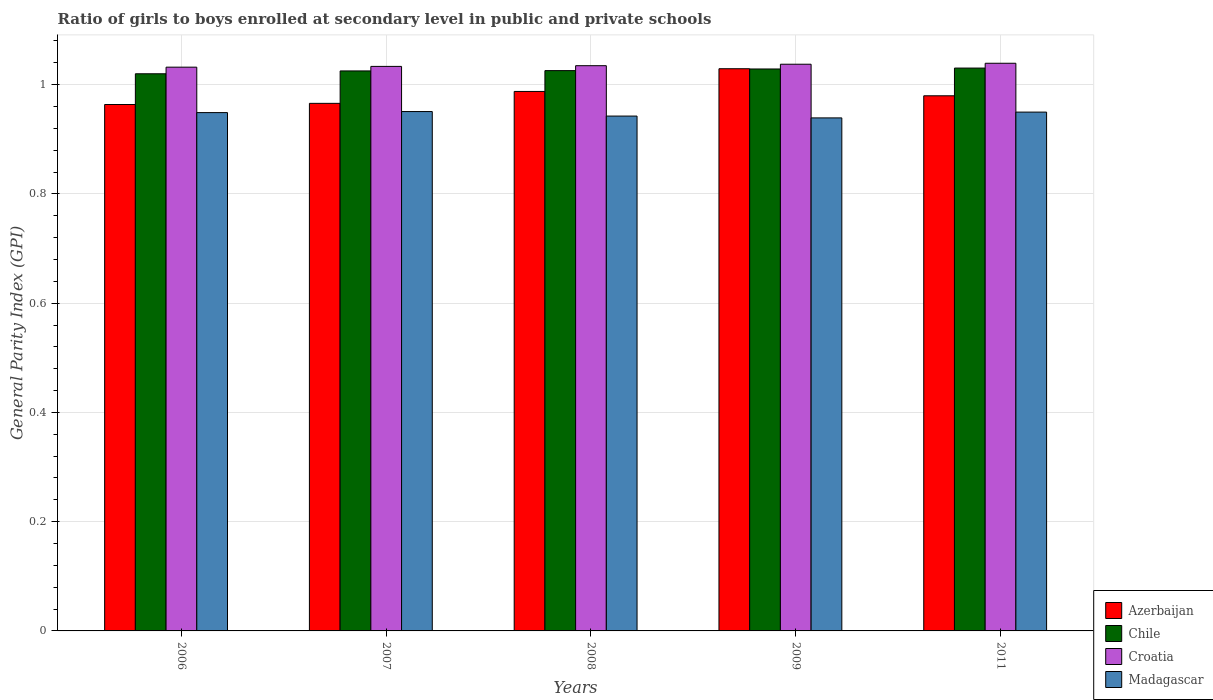What is the general parity index in Madagascar in 2008?
Provide a succinct answer. 0.94. Across all years, what is the maximum general parity index in Chile?
Provide a succinct answer. 1.03. Across all years, what is the minimum general parity index in Madagascar?
Provide a short and direct response. 0.94. In which year was the general parity index in Chile minimum?
Your response must be concise. 2006. What is the total general parity index in Azerbaijan in the graph?
Your answer should be very brief. 4.93. What is the difference between the general parity index in Chile in 2006 and that in 2008?
Provide a short and direct response. -0.01. What is the difference between the general parity index in Madagascar in 2011 and the general parity index in Chile in 2009?
Provide a succinct answer. -0.08. What is the average general parity index in Croatia per year?
Keep it short and to the point. 1.04. In the year 2006, what is the difference between the general parity index in Croatia and general parity index in Azerbaijan?
Give a very brief answer. 0.07. In how many years, is the general parity index in Madagascar greater than 0.04?
Your response must be concise. 5. What is the ratio of the general parity index in Croatia in 2007 to that in 2008?
Ensure brevity in your answer.  1. Is the difference between the general parity index in Croatia in 2007 and 2011 greater than the difference between the general parity index in Azerbaijan in 2007 and 2011?
Ensure brevity in your answer.  Yes. What is the difference between the highest and the second highest general parity index in Chile?
Make the answer very short. 0. What is the difference between the highest and the lowest general parity index in Madagascar?
Keep it short and to the point. 0.01. Is the sum of the general parity index in Azerbaijan in 2007 and 2008 greater than the maximum general parity index in Croatia across all years?
Ensure brevity in your answer.  Yes. Is it the case that in every year, the sum of the general parity index in Chile and general parity index in Azerbaijan is greater than the sum of general parity index in Croatia and general parity index in Madagascar?
Provide a succinct answer. Yes. What does the 4th bar from the left in 2007 represents?
Give a very brief answer. Madagascar. What does the 1st bar from the right in 2008 represents?
Provide a short and direct response. Madagascar. Is it the case that in every year, the sum of the general parity index in Madagascar and general parity index in Chile is greater than the general parity index in Croatia?
Keep it short and to the point. Yes. How many bars are there?
Your response must be concise. 20. Are all the bars in the graph horizontal?
Provide a short and direct response. No. Does the graph contain any zero values?
Offer a very short reply. No. Does the graph contain grids?
Offer a very short reply. Yes. How many legend labels are there?
Ensure brevity in your answer.  4. What is the title of the graph?
Give a very brief answer. Ratio of girls to boys enrolled at secondary level in public and private schools. What is the label or title of the X-axis?
Offer a very short reply. Years. What is the label or title of the Y-axis?
Offer a very short reply. General Parity Index (GPI). What is the General Parity Index (GPI) of Azerbaijan in 2006?
Offer a terse response. 0.96. What is the General Parity Index (GPI) of Chile in 2006?
Your answer should be compact. 1.02. What is the General Parity Index (GPI) in Croatia in 2006?
Provide a succinct answer. 1.03. What is the General Parity Index (GPI) of Madagascar in 2006?
Provide a short and direct response. 0.95. What is the General Parity Index (GPI) in Azerbaijan in 2007?
Keep it short and to the point. 0.97. What is the General Parity Index (GPI) in Chile in 2007?
Ensure brevity in your answer.  1.03. What is the General Parity Index (GPI) of Croatia in 2007?
Offer a very short reply. 1.03. What is the General Parity Index (GPI) of Madagascar in 2007?
Give a very brief answer. 0.95. What is the General Parity Index (GPI) of Azerbaijan in 2008?
Ensure brevity in your answer.  0.99. What is the General Parity Index (GPI) in Chile in 2008?
Offer a very short reply. 1.03. What is the General Parity Index (GPI) in Croatia in 2008?
Your answer should be compact. 1.03. What is the General Parity Index (GPI) of Madagascar in 2008?
Make the answer very short. 0.94. What is the General Parity Index (GPI) in Azerbaijan in 2009?
Ensure brevity in your answer.  1.03. What is the General Parity Index (GPI) in Chile in 2009?
Ensure brevity in your answer.  1.03. What is the General Parity Index (GPI) of Croatia in 2009?
Provide a succinct answer. 1.04. What is the General Parity Index (GPI) of Madagascar in 2009?
Provide a succinct answer. 0.94. What is the General Parity Index (GPI) in Azerbaijan in 2011?
Keep it short and to the point. 0.98. What is the General Parity Index (GPI) in Chile in 2011?
Provide a short and direct response. 1.03. What is the General Parity Index (GPI) of Croatia in 2011?
Give a very brief answer. 1.04. What is the General Parity Index (GPI) of Madagascar in 2011?
Provide a short and direct response. 0.95. Across all years, what is the maximum General Parity Index (GPI) of Azerbaijan?
Ensure brevity in your answer.  1.03. Across all years, what is the maximum General Parity Index (GPI) of Chile?
Your response must be concise. 1.03. Across all years, what is the maximum General Parity Index (GPI) in Croatia?
Keep it short and to the point. 1.04. Across all years, what is the maximum General Parity Index (GPI) of Madagascar?
Provide a short and direct response. 0.95. Across all years, what is the minimum General Parity Index (GPI) in Azerbaijan?
Make the answer very short. 0.96. Across all years, what is the minimum General Parity Index (GPI) of Chile?
Your answer should be compact. 1.02. Across all years, what is the minimum General Parity Index (GPI) of Croatia?
Give a very brief answer. 1.03. Across all years, what is the minimum General Parity Index (GPI) of Madagascar?
Offer a very short reply. 0.94. What is the total General Parity Index (GPI) in Azerbaijan in the graph?
Your answer should be compact. 4.93. What is the total General Parity Index (GPI) of Chile in the graph?
Make the answer very short. 5.13. What is the total General Parity Index (GPI) in Croatia in the graph?
Provide a short and direct response. 5.18. What is the total General Parity Index (GPI) in Madagascar in the graph?
Your answer should be compact. 4.73. What is the difference between the General Parity Index (GPI) of Azerbaijan in 2006 and that in 2007?
Offer a terse response. -0. What is the difference between the General Parity Index (GPI) in Chile in 2006 and that in 2007?
Ensure brevity in your answer.  -0.01. What is the difference between the General Parity Index (GPI) in Croatia in 2006 and that in 2007?
Your answer should be compact. -0. What is the difference between the General Parity Index (GPI) in Madagascar in 2006 and that in 2007?
Your response must be concise. -0. What is the difference between the General Parity Index (GPI) of Azerbaijan in 2006 and that in 2008?
Your answer should be very brief. -0.02. What is the difference between the General Parity Index (GPI) of Chile in 2006 and that in 2008?
Offer a very short reply. -0.01. What is the difference between the General Parity Index (GPI) of Croatia in 2006 and that in 2008?
Give a very brief answer. -0. What is the difference between the General Parity Index (GPI) in Madagascar in 2006 and that in 2008?
Your answer should be very brief. 0.01. What is the difference between the General Parity Index (GPI) in Azerbaijan in 2006 and that in 2009?
Your response must be concise. -0.07. What is the difference between the General Parity Index (GPI) in Chile in 2006 and that in 2009?
Your response must be concise. -0.01. What is the difference between the General Parity Index (GPI) of Croatia in 2006 and that in 2009?
Your answer should be very brief. -0.01. What is the difference between the General Parity Index (GPI) of Madagascar in 2006 and that in 2009?
Give a very brief answer. 0.01. What is the difference between the General Parity Index (GPI) in Azerbaijan in 2006 and that in 2011?
Keep it short and to the point. -0.02. What is the difference between the General Parity Index (GPI) of Chile in 2006 and that in 2011?
Keep it short and to the point. -0.01. What is the difference between the General Parity Index (GPI) in Croatia in 2006 and that in 2011?
Provide a succinct answer. -0.01. What is the difference between the General Parity Index (GPI) of Madagascar in 2006 and that in 2011?
Offer a terse response. -0. What is the difference between the General Parity Index (GPI) of Azerbaijan in 2007 and that in 2008?
Your answer should be very brief. -0.02. What is the difference between the General Parity Index (GPI) in Chile in 2007 and that in 2008?
Keep it short and to the point. -0. What is the difference between the General Parity Index (GPI) of Croatia in 2007 and that in 2008?
Provide a short and direct response. -0. What is the difference between the General Parity Index (GPI) in Madagascar in 2007 and that in 2008?
Ensure brevity in your answer.  0.01. What is the difference between the General Parity Index (GPI) in Azerbaijan in 2007 and that in 2009?
Keep it short and to the point. -0.06. What is the difference between the General Parity Index (GPI) in Chile in 2007 and that in 2009?
Make the answer very short. -0. What is the difference between the General Parity Index (GPI) of Croatia in 2007 and that in 2009?
Offer a terse response. -0. What is the difference between the General Parity Index (GPI) of Madagascar in 2007 and that in 2009?
Provide a succinct answer. 0.01. What is the difference between the General Parity Index (GPI) of Azerbaijan in 2007 and that in 2011?
Provide a succinct answer. -0.01. What is the difference between the General Parity Index (GPI) in Chile in 2007 and that in 2011?
Provide a short and direct response. -0.01. What is the difference between the General Parity Index (GPI) in Croatia in 2007 and that in 2011?
Keep it short and to the point. -0.01. What is the difference between the General Parity Index (GPI) in Azerbaijan in 2008 and that in 2009?
Keep it short and to the point. -0.04. What is the difference between the General Parity Index (GPI) in Chile in 2008 and that in 2009?
Give a very brief answer. -0. What is the difference between the General Parity Index (GPI) of Croatia in 2008 and that in 2009?
Your response must be concise. -0. What is the difference between the General Parity Index (GPI) of Madagascar in 2008 and that in 2009?
Keep it short and to the point. 0. What is the difference between the General Parity Index (GPI) in Azerbaijan in 2008 and that in 2011?
Offer a terse response. 0.01. What is the difference between the General Parity Index (GPI) in Chile in 2008 and that in 2011?
Ensure brevity in your answer.  -0. What is the difference between the General Parity Index (GPI) in Croatia in 2008 and that in 2011?
Keep it short and to the point. -0. What is the difference between the General Parity Index (GPI) in Madagascar in 2008 and that in 2011?
Your answer should be very brief. -0.01. What is the difference between the General Parity Index (GPI) of Azerbaijan in 2009 and that in 2011?
Your answer should be compact. 0.05. What is the difference between the General Parity Index (GPI) of Chile in 2009 and that in 2011?
Provide a short and direct response. -0. What is the difference between the General Parity Index (GPI) of Croatia in 2009 and that in 2011?
Provide a short and direct response. -0. What is the difference between the General Parity Index (GPI) of Madagascar in 2009 and that in 2011?
Provide a succinct answer. -0.01. What is the difference between the General Parity Index (GPI) of Azerbaijan in 2006 and the General Parity Index (GPI) of Chile in 2007?
Provide a short and direct response. -0.06. What is the difference between the General Parity Index (GPI) in Azerbaijan in 2006 and the General Parity Index (GPI) in Croatia in 2007?
Make the answer very short. -0.07. What is the difference between the General Parity Index (GPI) in Azerbaijan in 2006 and the General Parity Index (GPI) in Madagascar in 2007?
Provide a short and direct response. 0.01. What is the difference between the General Parity Index (GPI) in Chile in 2006 and the General Parity Index (GPI) in Croatia in 2007?
Offer a very short reply. -0.01. What is the difference between the General Parity Index (GPI) in Chile in 2006 and the General Parity Index (GPI) in Madagascar in 2007?
Make the answer very short. 0.07. What is the difference between the General Parity Index (GPI) of Croatia in 2006 and the General Parity Index (GPI) of Madagascar in 2007?
Offer a very short reply. 0.08. What is the difference between the General Parity Index (GPI) of Azerbaijan in 2006 and the General Parity Index (GPI) of Chile in 2008?
Offer a terse response. -0.06. What is the difference between the General Parity Index (GPI) of Azerbaijan in 2006 and the General Parity Index (GPI) of Croatia in 2008?
Make the answer very short. -0.07. What is the difference between the General Parity Index (GPI) of Azerbaijan in 2006 and the General Parity Index (GPI) of Madagascar in 2008?
Provide a succinct answer. 0.02. What is the difference between the General Parity Index (GPI) in Chile in 2006 and the General Parity Index (GPI) in Croatia in 2008?
Offer a very short reply. -0.01. What is the difference between the General Parity Index (GPI) in Chile in 2006 and the General Parity Index (GPI) in Madagascar in 2008?
Offer a terse response. 0.08. What is the difference between the General Parity Index (GPI) in Croatia in 2006 and the General Parity Index (GPI) in Madagascar in 2008?
Keep it short and to the point. 0.09. What is the difference between the General Parity Index (GPI) of Azerbaijan in 2006 and the General Parity Index (GPI) of Chile in 2009?
Your response must be concise. -0.07. What is the difference between the General Parity Index (GPI) in Azerbaijan in 2006 and the General Parity Index (GPI) in Croatia in 2009?
Provide a succinct answer. -0.07. What is the difference between the General Parity Index (GPI) of Azerbaijan in 2006 and the General Parity Index (GPI) of Madagascar in 2009?
Keep it short and to the point. 0.02. What is the difference between the General Parity Index (GPI) in Chile in 2006 and the General Parity Index (GPI) in Croatia in 2009?
Your response must be concise. -0.02. What is the difference between the General Parity Index (GPI) in Chile in 2006 and the General Parity Index (GPI) in Madagascar in 2009?
Your response must be concise. 0.08. What is the difference between the General Parity Index (GPI) in Croatia in 2006 and the General Parity Index (GPI) in Madagascar in 2009?
Give a very brief answer. 0.09. What is the difference between the General Parity Index (GPI) in Azerbaijan in 2006 and the General Parity Index (GPI) in Chile in 2011?
Give a very brief answer. -0.07. What is the difference between the General Parity Index (GPI) of Azerbaijan in 2006 and the General Parity Index (GPI) of Croatia in 2011?
Make the answer very short. -0.08. What is the difference between the General Parity Index (GPI) of Azerbaijan in 2006 and the General Parity Index (GPI) of Madagascar in 2011?
Your response must be concise. 0.01. What is the difference between the General Parity Index (GPI) in Chile in 2006 and the General Parity Index (GPI) in Croatia in 2011?
Your response must be concise. -0.02. What is the difference between the General Parity Index (GPI) of Chile in 2006 and the General Parity Index (GPI) of Madagascar in 2011?
Ensure brevity in your answer.  0.07. What is the difference between the General Parity Index (GPI) of Croatia in 2006 and the General Parity Index (GPI) of Madagascar in 2011?
Offer a very short reply. 0.08. What is the difference between the General Parity Index (GPI) of Azerbaijan in 2007 and the General Parity Index (GPI) of Chile in 2008?
Provide a short and direct response. -0.06. What is the difference between the General Parity Index (GPI) of Azerbaijan in 2007 and the General Parity Index (GPI) of Croatia in 2008?
Your answer should be very brief. -0.07. What is the difference between the General Parity Index (GPI) of Azerbaijan in 2007 and the General Parity Index (GPI) of Madagascar in 2008?
Your answer should be compact. 0.02. What is the difference between the General Parity Index (GPI) in Chile in 2007 and the General Parity Index (GPI) in Croatia in 2008?
Ensure brevity in your answer.  -0.01. What is the difference between the General Parity Index (GPI) of Chile in 2007 and the General Parity Index (GPI) of Madagascar in 2008?
Offer a terse response. 0.08. What is the difference between the General Parity Index (GPI) of Croatia in 2007 and the General Parity Index (GPI) of Madagascar in 2008?
Your answer should be compact. 0.09. What is the difference between the General Parity Index (GPI) in Azerbaijan in 2007 and the General Parity Index (GPI) in Chile in 2009?
Your answer should be very brief. -0.06. What is the difference between the General Parity Index (GPI) of Azerbaijan in 2007 and the General Parity Index (GPI) of Croatia in 2009?
Your answer should be very brief. -0.07. What is the difference between the General Parity Index (GPI) of Azerbaijan in 2007 and the General Parity Index (GPI) of Madagascar in 2009?
Provide a short and direct response. 0.03. What is the difference between the General Parity Index (GPI) of Chile in 2007 and the General Parity Index (GPI) of Croatia in 2009?
Provide a short and direct response. -0.01. What is the difference between the General Parity Index (GPI) of Chile in 2007 and the General Parity Index (GPI) of Madagascar in 2009?
Provide a short and direct response. 0.09. What is the difference between the General Parity Index (GPI) of Croatia in 2007 and the General Parity Index (GPI) of Madagascar in 2009?
Make the answer very short. 0.09. What is the difference between the General Parity Index (GPI) in Azerbaijan in 2007 and the General Parity Index (GPI) in Chile in 2011?
Your answer should be very brief. -0.06. What is the difference between the General Parity Index (GPI) of Azerbaijan in 2007 and the General Parity Index (GPI) of Croatia in 2011?
Give a very brief answer. -0.07. What is the difference between the General Parity Index (GPI) in Azerbaijan in 2007 and the General Parity Index (GPI) in Madagascar in 2011?
Your response must be concise. 0.02. What is the difference between the General Parity Index (GPI) of Chile in 2007 and the General Parity Index (GPI) of Croatia in 2011?
Offer a very short reply. -0.01. What is the difference between the General Parity Index (GPI) of Chile in 2007 and the General Parity Index (GPI) of Madagascar in 2011?
Offer a very short reply. 0.08. What is the difference between the General Parity Index (GPI) of Croatia in 2007 and the General Parity Index (GPI) of Madagascar in 2011?
Your response must be concise. 0.08. What is the difference between the General Parity Index (GPI) in Azerbaijan in 2008 and the General Parity Index (GPI) in Chile in 2009?
Provide a succinct answer. -0.04. What is the difference between the General Parity Index (GPI) in Azerbaijan in 2008 and the General Parity Index (GPI) in Croatia in 2009?
Your answer should be compact. -0.05. What is the difference between the General Parity Index (GPI) in Azerbaijan in 2008 and the General Parity Index (GPI) in Madagascar in 2009?
Make the answer very short. 0.05. What is the difference between the General Parity Index (GPI) of Chile in 2008 and the General Parity Index (GPI) of Croatia in 2009?
Your answer should be compact. -0.01. What is the difference between the General Parity Index (GPI) of Chile in 2008 and the General Parity Index (GPI) of Madagascar in 2009?
Keep it short and to the point. 0.09. What is the difference between the General Parity Index (GPI) in Croatia in 2008 and the General Parity Index (GPI) in Madagascar in 2009?
Make the answer very short. 0.1. What is the difference between the General Parity Index (GPI) in Azerbaijan in 2008 and the General Parity Index (GPI) in Chile in 2011?
Ensure brevity in your answer.  -0.04. What is the difference between the General Parity Index (GPI) of Azerbaijan in 2008 and the General Parity Index (GPI) of Croatia in 2011?
Give a very brief answer. -0.05. What is the difference between the General Parity Index (GPI) in Azerbaijan in 2008 and the General Parity Index (GPI) in Madagascar in 2011?
Ensure brevity in your answer.  0.04. What is the difference between the General Parity Index (GPI) in Chile in 2008 and the General Parity Index (GPI) in Croatia in 2011?
Your answer should be compact. -0.01. What is the difference between the General Parity Index (GPI) in Chile in 2008 and the General Parity Index (GPI) in Madagascar in 2011?
Provide a short and direct response. 0.08. What is the difference between the General Parity Index (GPI) in Croatia in 2008 and the General Parity Index (GPI) in Madagascar in 2011?
Offer a terse response. 0.09. What is the difference between the General Parity Index (GPI) in Azerbaijan in 2009 and the General Parity Index (GPI) in Chile in 2011?
Offer a terse response. -0. What is the difference between the General Parity Index (GPI) of Azerbaijan in 2009 and the General Parity Index (GPI) of Croatia in 2011?
Provide a succinct answer. -0.01. What is the difference between the General Parity Index (GPI) in Azerbaijan in 2009 and the General Parity Index (GPI) in Madagascar in 2011?
Give a very brief answer. 0.08. What is the difference between the General Parity Index (GPI) in Chile in 2009 and the General Parity Index (GPI) in Croatia in 2011?
Provide a succinct answer. -0.01. What is the difference between the General Parity Index (GPI) of Chile in 2009 and the General Parity Index (GPI) of Madagascar in 2011?
Your answer should be compact. 0.08. What is the difference between the General Parity Index (GPI) of Croatia in 2009 and the General Parity Index (GPI) of Madagascar in 2011?
Offer a terse response. 0.09. What is the average General Parity Index (GPI) of Azerbaijan per year?
Ensure brevity in your answer.  0.99. What is the average General Parity Index (GPI) of Chile per year?
Your answer should be very brief. 1.03. What is the average General Parity Index (GPI) in Croatia per year?
Offer a terse response. 1.04. What is the average General Parity Index (GPI) in Madagascar per year?
Offer a very short reply. 0.95. In the year 2006, what is the difference between the General Parity Index (GPI) of Azerbaijan and General Parity Index (GPI) of Chile?
Your answer should be very brief. -0.06. In the year 2006, what is the difference between the General Parity Index (GPI) in Azerbaijan and General Parity Index (GPI) in Croatia?
Keep it short and to the point. -0.07. In the year 2006, what is the difference between the General Parity Index (GPI) of Azerbaijan and General Parity Index (GPI) of Madagascar?
Keep it short and to the point. 0.01. In the year 2006, what is the difference between the General Parity Index (GPI) in Chile and General Parity Index (GPI) in Croatia?
Provide a succinct answer. -0.01. In the year 2006, what is the difference between the General Parity Index (GPI) in Chile and General Parity Index (GPI) in Madagascar?
Keep it short and to the point. 0.07. In the year 2006, what is the difference between the General Parity Index (GPI) in Croatia and General Parity Index (GPI) in Madagascar?
Your answer should be very brief. 0.08. In the year 2007, what is the difference between the General Parity Index (GPI) in Azerbaijan and General Parity Index (GPI) in Chile?
Provide a succinct answer. -0.06. In the year 2007, what is the difference between the General Parity Index (GPI) in Azerbaijan and General Parity Index (GPI) in Croatia?
Your answer should be compact. -0.07. In the year 2007, what is the difference between the General Parity Index (GPI) of Azerbaijan and General Parity Index (GPI) of Madagascar?
Provide a short and direct response. 0.01. In the year 2007, what is the difference between the General Parity Index (GPI) of Chile and General Parity Index (GPI) of Croatia?
Provide a succinct answer. -0.01. In the year 2007, what is the difference between the General Parity Index (GPI) of Chile and General Parity Index (GPI) of Madagascar?
Keep it short and to the point. 0.07. In the year 2007, what is the difference between the General Parity Index (GPI) of Croatia and General Parity Index (GPI) of Madagascar?
Your answer should be very brief. 0.08. In the year 2008, what is the difference between the General Parity Index (GPI) in Azerbaijan and General Parity Index (GPI) in Chile?
Provide a short and direct response. -0.04. In the year 2008, what is the difference between the General Parity Index (GPI) in Azerbaijan and General Parity Index (GPI) in Croatia?
Offer a very short reply. -0.05. In the year 2008, what is the difference between the General Parity Index (GPI) of Azerbaijan and General Parity Index (GPI) of Madagascar?
Ensure brevity in your answer.  0.05. In the year 2008, what is the difference between the General Parity Index (GPI) of Chile and General Parity Index (GPI) of Croatia?
Provide a short and direct response. -0.01. In the year 2008, what is the difference between the General Parity Index (GPI) in Chile and General Parity Index (GPI) in Madagascar?
Keep it short and to the point. 0.08. In the year 2008, what is the difference between the General Parity Index (GPI) in Croatia and General Parity Index (GPI) in Madagascar?
Keep it short and to the point. 0.09. In the year 2009, what is the difference between the General Parity Index (GPI) in Azerbaijan and General Parity Index (GPI) in Chile?
Offer a terse response. 0. In the year 2009, what is the difference between the General Parity Index (GPI) of Azerbaijan and General Parity Index (GPI) of Croatia?
Provide a short and direct response. -0.01. In the year 2009, what is the difference between the General Parity Index (GPI) in Azerbaijan and General Parity Index (GPI) in Madagascar?
Make the answer very short. 0.09. In the year 2009, what is the difference between the General Parity Index (GPI) in Chile and General Parity Index (GPI) in Croatia?
Make the answer very short. -0.01. In the year 2009, what is the difference between the General Parity Index (GPI) in Chile and General Parity Index (GPI) in Madagascar?
Your response must be concise. 0.09. In the year 2009, what is the difference between the General Parity Index (GPI) in Croatia and General Parity Index (GPI) in Madagascar?
Your answer should be compact. 0.1. In the year 2011, what is the difference between the General Parity Index (GPI) in Azerbaijan and General Parity Index (GPI) in Chile?
Offer a terse response. -0.05. In the year 2011, what is the difference between the General Parity Index (GPI) of Azerbaijan and General Parity Index (GPI) of Croatia?
Ensure brevity in your answer.  -0.06. In the year 2011, what is the difference between the General Parity Index (GPI) of Azerbaijan and General Parity Index (GPI) of Madagascar?
Your answer should be compact. 0.03. In the year 2011, what is the difference between the General Parity Index (GPI) of Chile and General Parity Index (GPI) of Croatia?
Your answer should be very brief. -0.01. In the year 2011, what is the difference between the General Parity Index (GPI) of Chile and General Parity Index (GPI) of Madagascar?
Offer a very short reply. 0.08. In the year 2011, what is the difference between the General Parity Index (GPI) of Croatia and General Parity Index (GPI) of Madagascar?
Provide a short and direct response. 0.09. What is the ratio of the General Parity Index (GPI) in Azerbaijan in 2006 to that in 2007?
Your answer should be compact. 1. What is the ratio of the General Parity Index (GPI) of Chile in 2006 to that in 2007?
Ensure brevity in your answer.  0.99. What is the ratio of the General Parity Index (GPI) in Croatia in 2006 to that in 2007?
Make the answer very short. 1. What is the ratio of the General Parity Index (GPI) of Madagascar in 2006 to that in 2007?
Your answer should be compact. 1. What is the ratio of the General Parity Index (GPI) of Azerbaijan in 2006 to that in 2008?
Provide a succinct answer. 0.98. What is the ratio of the General Parity Index (GPI) in Chile in 2006 to that in 2008?
Keep it short and to the point. 0.99. What is the ratio of the General Parity Index (GPI) in Croatia in 2006 to that in 2008?
Offer a very short reply. 1. What is the ratio of the General Parity Index (GPI) in Azerbaijan in 2006 to that in 2009?
Provide a short and direct response. 0.94. What is the ratio of the General Parity Index (GPI) of Chile in 2006 to that in 2009?
Ensure brevity in your answer.  0.99. What is the ratio of the General Parity Index (GPI) in Madagascar in 2006 to that in 2009?
Offer a terse response. 1.01. What is the ratio of the General Parity Index (GPI) of Azerbaijan in 2006 to that in 2011?
Your answer should be compact. 0.98. What is the ratio of the General Parity Index (GPI) of Croatia in 2006 to that in 2011?
Offer a terse response. 0.99. What is the ratio of the General Parity Index (GPI) of Azerbaijan in 2007 to that in 2008?
Give a very brief answer. 0.98. What is the ratio of the General Parity Index (GPI) in Chile in 2007 to that in 2008?
Your answer should be compact. 1. What is the ratio of the General Parity Index (GPI) of Croatia in 2007 to that in 2008?
Offer a very short reply. 1. What is the ratio of the General Parity Index (GPI) of Madagascar in 2007 to that in 2008?
Offer a very short reply. 1.01. What is the ratio of the General Parity Index (GPI) of Azerbaijan in 2007 to that in 2009?
Offer a terse response. 0.94. What is the ratio of the General Parity Index (GPI) of Chile in 2007 to that in 2009?
Offer a very short reply. 1. What is the ratio of the General Parity Index (GPI) of Madagascar in 2007 to that in 2009?
Offer a very short reply. 1.01. What is the ratio of the General Parity Index (GPI) of Azerbaijan in 2007 to that in 2011?
Make the answer very short. 0.99. What is the ratio of the General Parity Index (GPI) of Madagascar in 2007 to that in 2011?
Keep it short and to the point. 1. What is the ratio of the General Parity Index (GPI) of Azerbaijan in 2008 to that in 2009?
Offer a very short reply. 0.96. What is the ratio of the General Parity Index (GPI) in Chile in 2008 to that in 2009?
Make the answer very short. 1. What is the ratio of the General Parity Index (GPI) of Croatia in 2008 to that in 2009?
Your answer should be very brief. 1. What is the ratio of the General Parity Index (GPI) of Croatia in 2008 to that in 2011?
Offer a terse response. 1. What is the ratio of the General Parity Index (GPI) in Madagascar in 2008 to that in 2011?
Give a very brief answer. 0.99. What is the ratio of the General Parity Index (GPI) in Azerbaijan in 2009 to that in 2011?
Offer a terse response. 1.05. What is the ratio of the General Parity Index (GPI) in Chile in 2009 to that in 2011?
Your response must be concise. 1. What is the ratio of the General Parity Index (GPI) in Madagascar in 2009 to that in 2011?
Offer a very short reply. 0.99. What is the difference between the highest and the second highest General Parity Index (GPI) of Azerbaijan?
Offer a terse response. 0.04. What is the difference between the highest and the second highest General Parity Index (GPI) of Chile?
Make the answer very short. 0. What is the difference between the highest and the second highest General Parity Index (GPI) in Croatia?
Make the answer very short. 0. What is the difference between the highest and the second highest General Parity Index (GPI) of Madagascar?
Ensure brevity in your answer.  0. What is the difference between the highest and the lowest General Parity Index (GPI) of Azerbaijan?
Your answer should be compact. 0.07. What is the difference between the highest and the lowest General Parity Index (GPI) in Chile?
Your response must be concise. 0.01. What is the difference between the highest and the lowest General Parity Index (GPI) of Croatia?
Give a very brief answer. 0.01. What is the difference between the highest and the lowest General Parity Index (GPI) of Madagascar?
Provide a short and direct response. 0.01. 